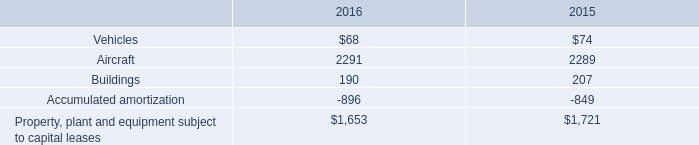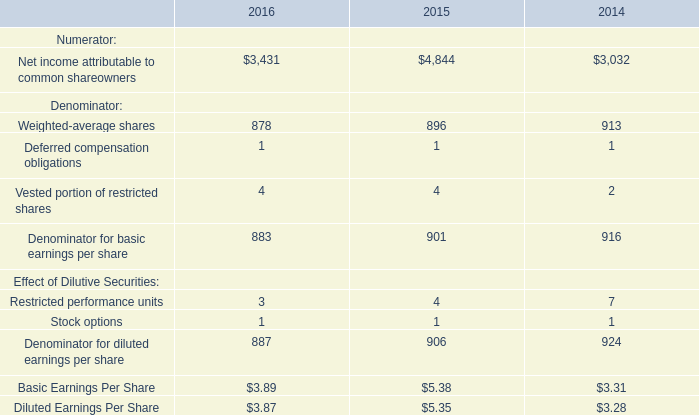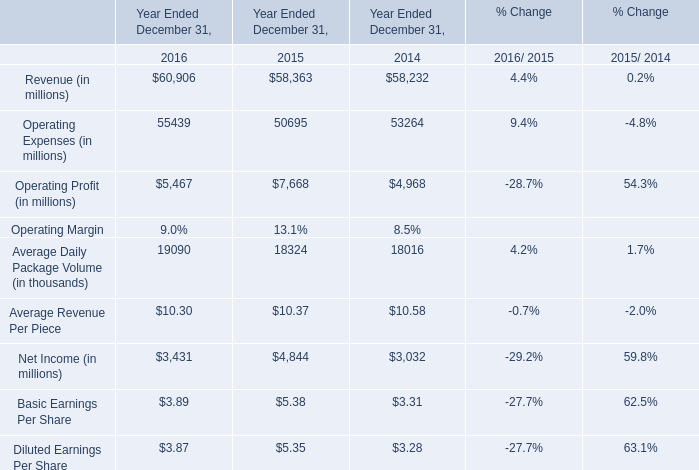What's the total amount of the Operating Profit in the years where Weighted-average shares for Denominator is greater than 0? (in million) 
Computations: ((5467 + 7668) + 4968)
Answer: 18103.0. 